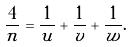<formula> <loc_0><loc_0><loc_500><loc_500>\frac { 4 } { n } = \frac { 1 } { u } + \frac { 1 } { v } + \frac { 1 } { w } .</formula> 